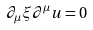<formula> <loc_0><loc_0><loc_500><loc_500>\partial _ { \mu } \xi \partial ^ { \mu } u = 0</formula> 